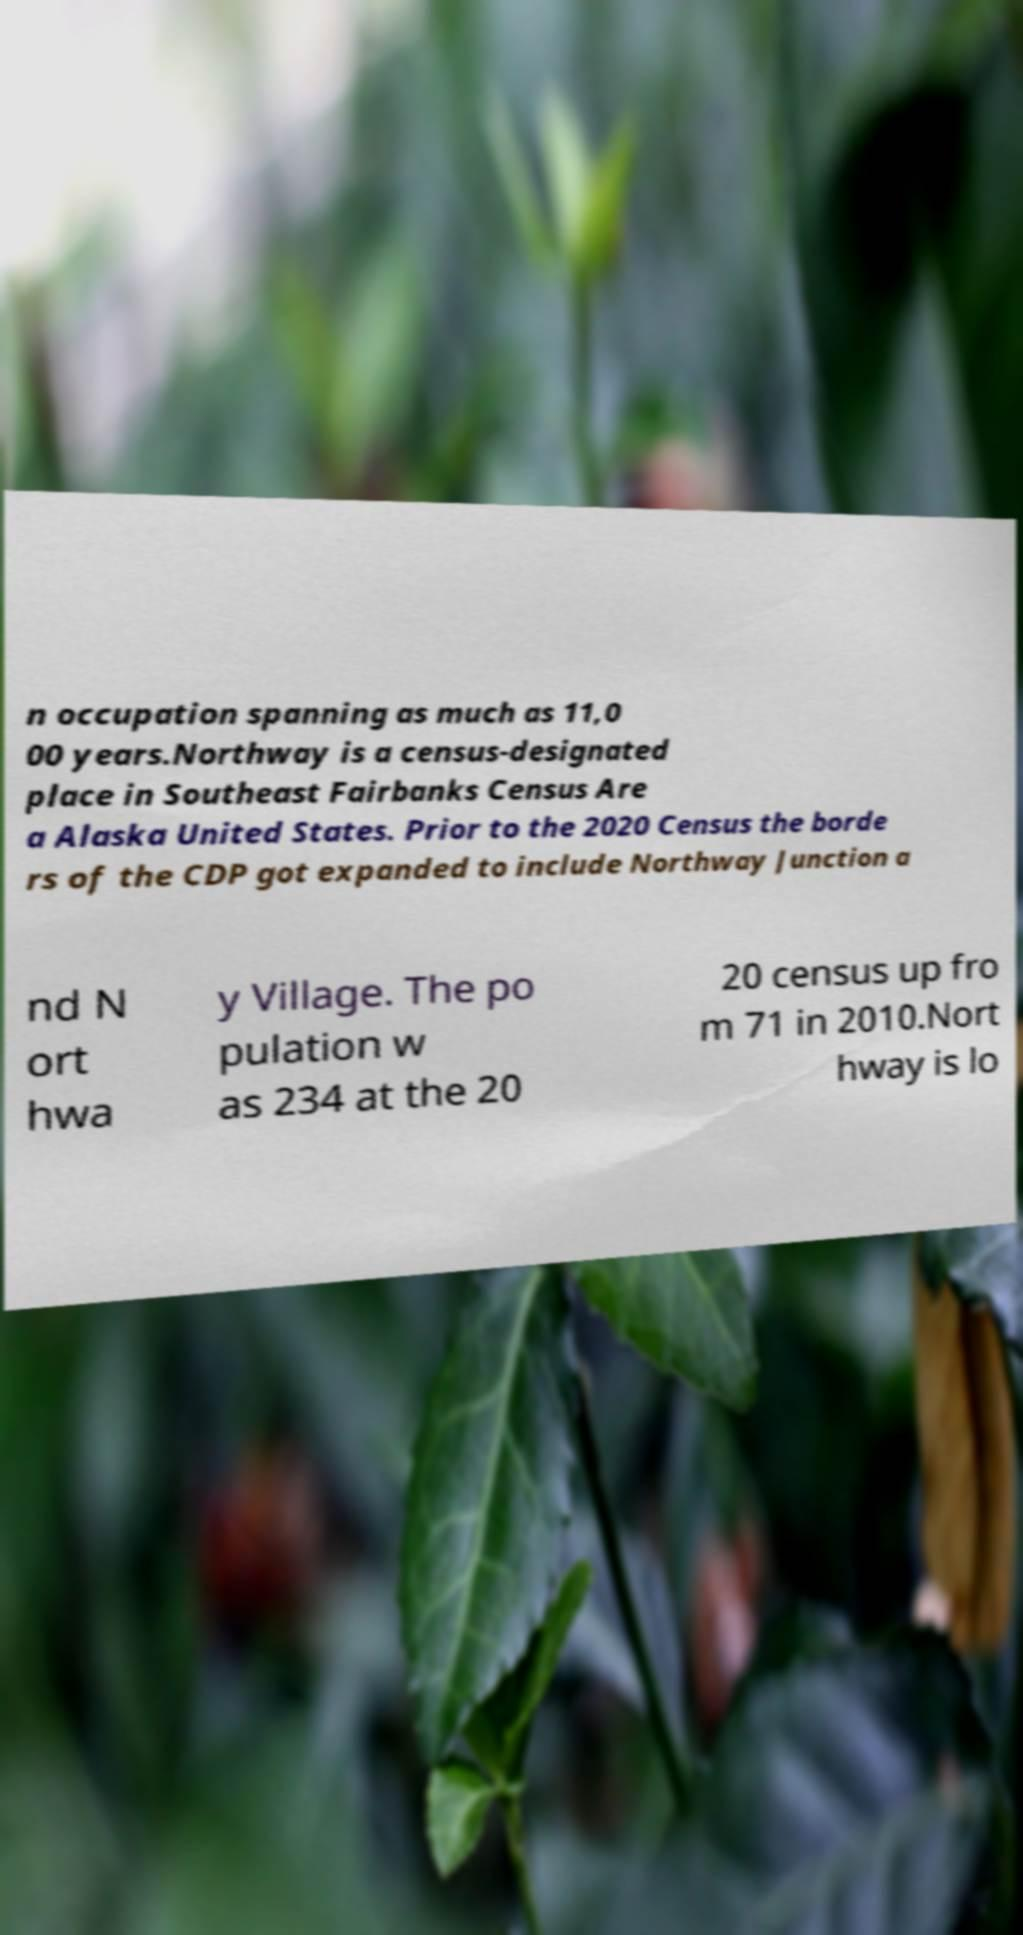For documentation purposes, I need the text within this image transcribed. Could you provide that? n occupation spanning as much as 11,0 00 years.Northway is a census-designated place in Southeast Fairbanks Census Are a Alaska United States. Prior to the 2020 Census the borde rs of the CDP got expanded to include Northway Junction a nd N ort hwa y Village. The po pulation w as 234 at the 20 20 census up fro m 71 in 2010.Nort hway is lo 